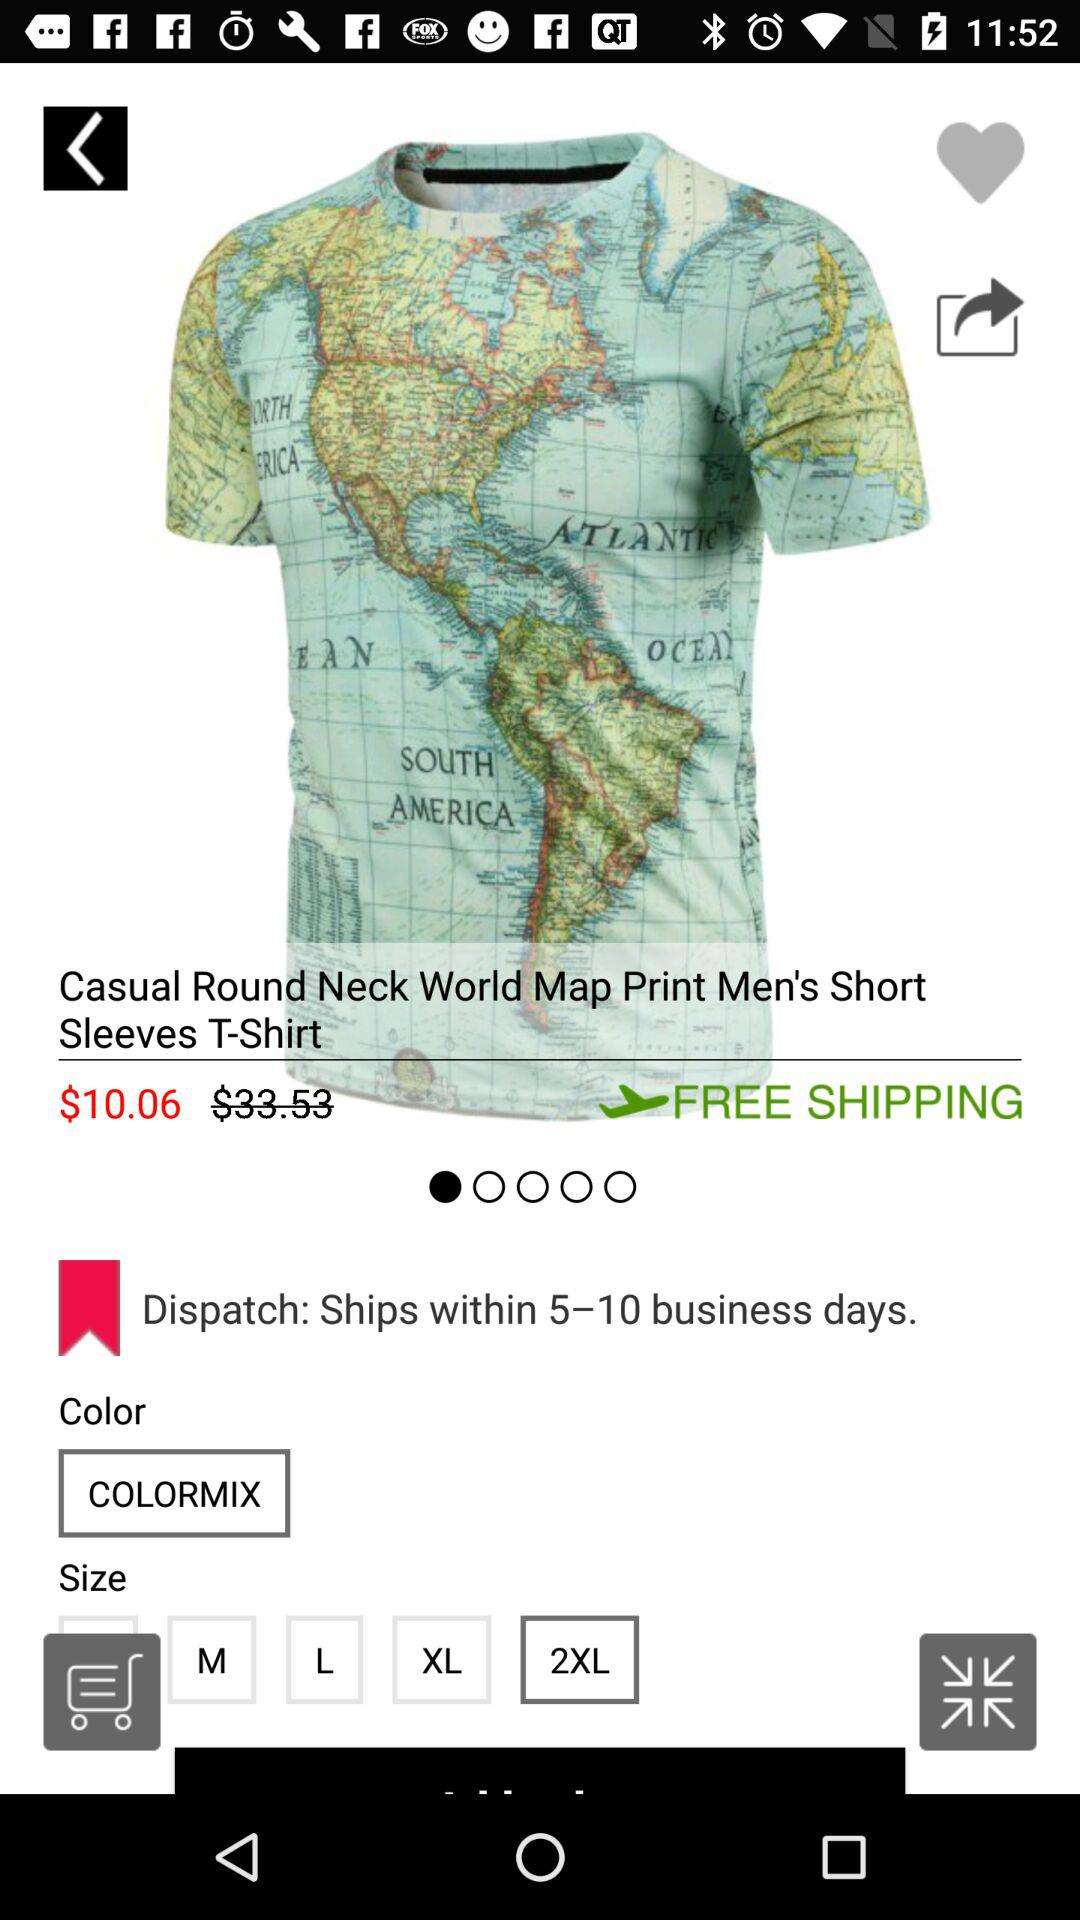What is the selected color? The selected color is "Colormix". 